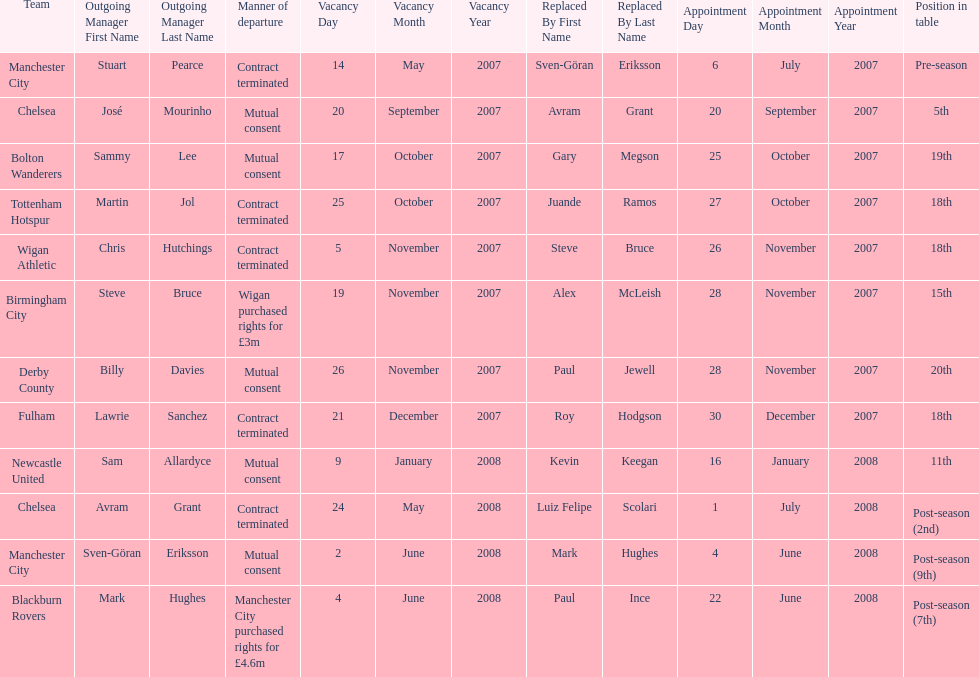What was the top team according to position in table called? Manchester City. 